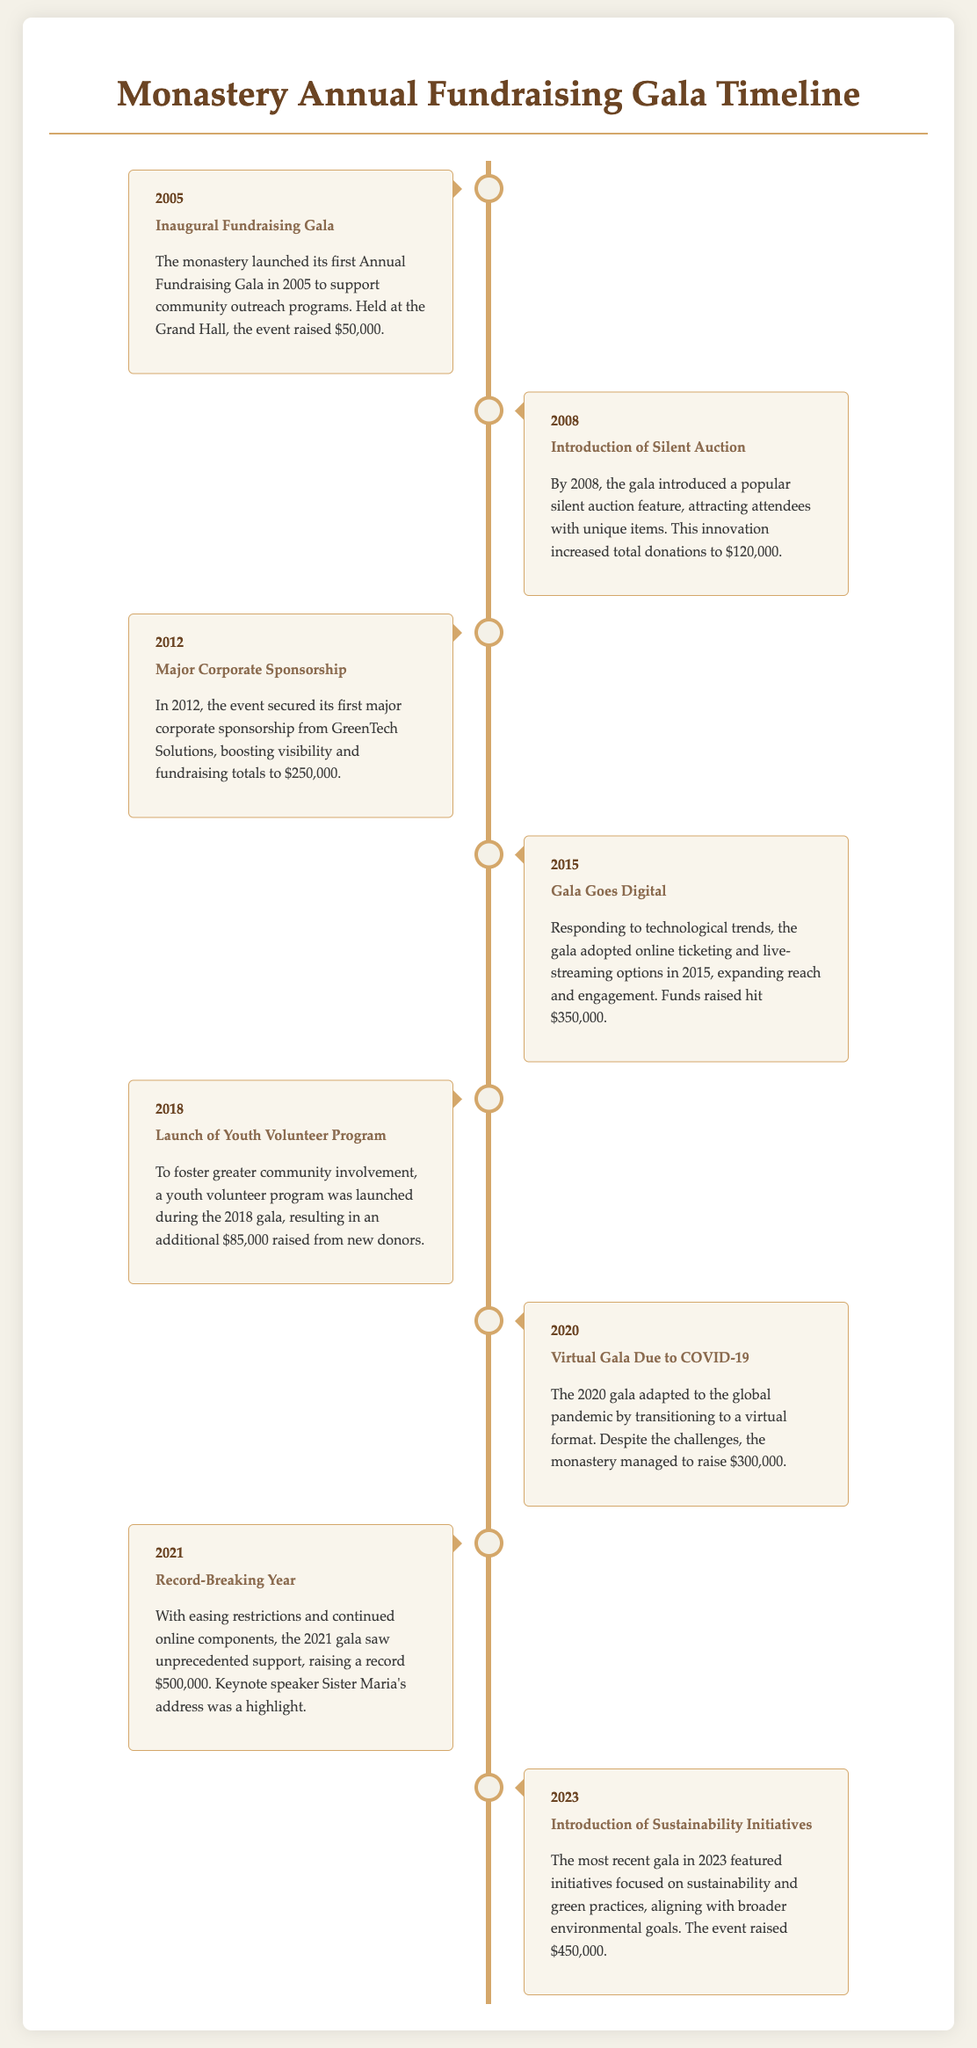What year did the inaugural gala take place? The document states that the inaugural gala was held in 2005.
Answer: 2005 What was the total amount raised in 2015? According to the timeline, the gala raised $350,000 in 2015.
Answer: $350,000 Which company sponsored the gala in 2012? The document mentions that GreenTech Solutions was the major corporate sponsor in 2012.
Answer: GreenTech Solutions How much money was raised for the most recent gala in 2023? The 2023 gala raised $450,000 as stated in the timeline.
Answer: $450,000 What significant feature was introduced in 2008? The timeline indicates that a silent auction feature was introduced in 2008.
Answer: Silent auction Which year saw a record-breaking amount raised? The timeline highlights that the year 2021 broke the previous fundraising record.
Answer: 2021 What kind of format did the gala take in 2020? The document specifies that the gala was conducted in a virtual format in 2020.
Answer: Virtual What initiative was introduced during the 2023 gala? The timeline mentions a focus on sustainability initiatives at the 2023 gala.
Answer: Sustainability initiatives How much additional revenue was raised from the youth volunteer program in 2018? The document states that the youth volunteer program helped raise an additional $85,000 in 2018.
Answer: $85,000 